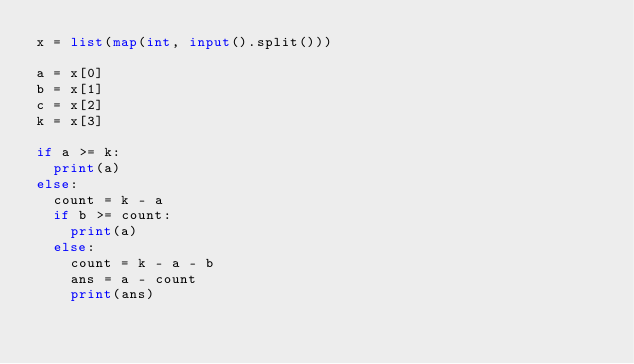<code> <loc_0><loc_0><loc_500><loc_500><_Python_>x = list(map(int, input().split()))

a = x[0]
b = x[1]
c = x[2]
k = x[3]

if a >= k:
  print(a)
else:
  count = k - a
  if b >= count:
    print(a)
  else:
    count = k - a - b
    ans = a - count
    print(ans)</code> 